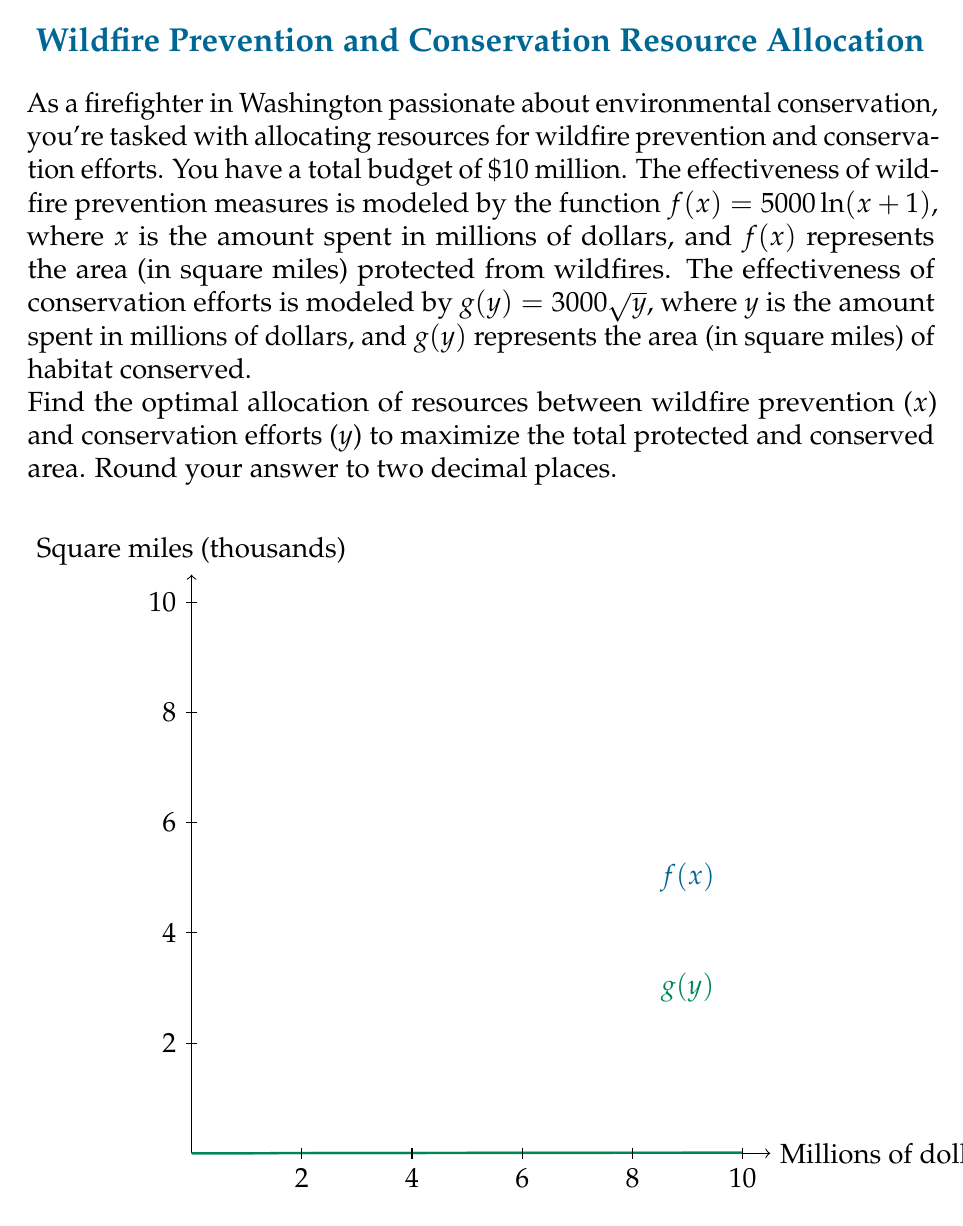Teach me how to tackle this problem. Let's approach this step-by-step:

1) We want to maximize the total area, which is $f(x) + g(y)$, subject to the constraint that $x + y = 10$ (total budget).

2) We can express this as an optimization problem:

   Maximize: $h(x) = f(x) + g(10-x) = 5000\ln(x+1) + 3000\sqrt{10-x}$

3) To find the maximum, we differentiate $h(x)$ and set it to zero:

   $$h'(x) = \frac{5000}{x+1} - \frac{3000}{2\sqrt{10-x}} = 0$$

4) Multiply both sides by $2(x+1)\sqrt{10-x}$:

   $$10000\sqrt{10-x} - 3000(x+1) = 0$$

5) Square both sides:

   $$100000000(10-x) = 9000000(x+1)^2$$

6) Expand:

   $$1000000000 - 100000000x = 9000000x^2 + 18000000x + 9000000$$

7) Rearrange:

   $$9000000x^2 + 118000000x - 991000000 = 0$$

8) Divide by 9000000:

   $$x^2 + \frac{118}{9}x - \frac{991}{9} = 0$$

9) Solve this quadratic equation:

   $$x = \frac{-118/9 \pm \sqrt{(118/9)^2 + 4(991/9)}}{2} \approx 5.86 \text{ or } -18.97$$

10) Since $x$ represents money spent, it must be positive, so we take the positive solution.

11) Therefore, $x \approx 5.86$ million should be spent on wildfire prevention, and $y = 10 - 5.86 = 4.14$ million on conservation efforts.
Answer: $5.86 million on wildfire prevention, $4.14 million on conservation 